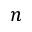<formula> <loc_0><loc_0><loc_500><loc_500>n</formula> 